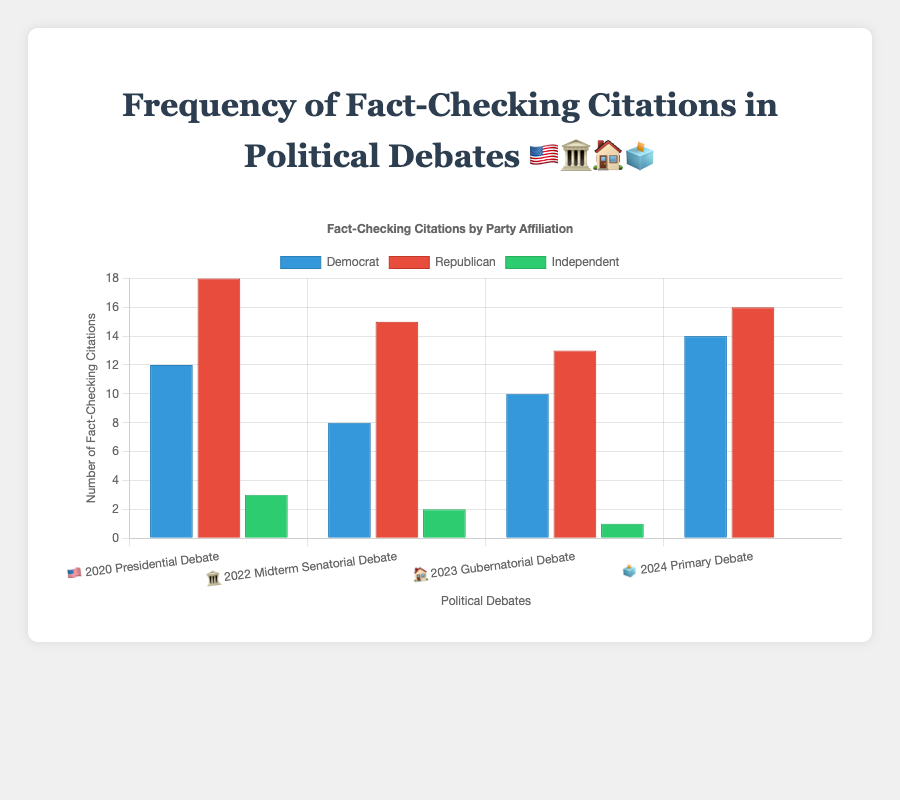what does the title of the figure say? The title of the figure is "Frequency of Fact-Checking Citations in Political Debates 🇺🇸🏛️🏠🗳️", which indicates the scope of the figure and uses emojis to represent different debates.
Answer: "Frequency of Fact-Checking Citations in Political Debates 🇺🇸🏛️🏠🗳️" How many fact-checking citations did Democrats receive on average across the debates? Add the citations Democrats received in each debate: (12 + 8 + 10 + 14) = 44. Divide by the number of debates: 44 / 4 = 11.
Answer: 11 Which debate had the highest number of fact-checking citations for Republicans? Check each debate’s citations for Republicans. The "2020 Presidential Debate" had the highest with 18 citations.
Answer: 2020 Presidential Debate What's the total number of fact-checking citations for Independent participants in all debates combined? Add the citations Independents received in each debate: 3 + 2 + 1 + 0 = 6.
Answer: 6 Which party had the least fact-checking citations in the 2024 Primary Debate? Check the citations for each party in the 2024 Primary Debate: Democrat (14), Republican (16), Independent (0). Independents had the least with 0 citations.
Answer: Independent Compare the fact-checking citations between Democrats and Republicans in the 2022 Midterm Senatorial Debate. Which party had more citations? Democrats had 8 citations and Republicans had 15. Republicans had more citations.
Answer: Republicans What is the overall trend for Independent fact-checking citations across the debates? Observe the data points for Independents: 3, 2, 1, 0. The trend shows a consistent decrease.
Answer: Decreasing How do the fact-checking citations for the "2023 Gubernatorial Debate" compare between Republicans and Independents? In the "2023 Gubernatorial Debate", Republicans had 13 citations and Independents had 1, demonstrating a significant difference.
Answer: Republicans By how much did the fact-checking citations for Democrats increase from the 2022 Midterm Senatorial Debate to the 2024 Primary Debate? Subtract the 2022 citations from the 2024 citations for Democrats: 14 - 8 = 6. The increase is 6.
Answer: 6 